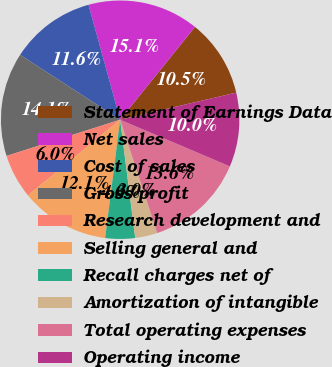Convert chart to OTSL. <chart><loc_0><loc_0><loc_500><loc_500><pie_chart><fcel>Statement of Earnings Data<fcel>Net sales<fcel>Cost of sales<fcel>Gross profit<fcel>Research development and<fcel>Selling general and<fcel>Recall charges net of<fcel>Amortization of intangible<fcel>Total operating expenses<fcel>Operating income<nl><fcel>10.55%<fcel>15.08%<fcel>11.56%<fcel>14.07%<fcel>6.03%<fcel>12.06%<fcel>4.02%<fcel>3.02%<fcel>13.57%<fcel>10.05%<nl></chart> 